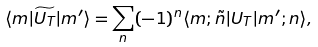Convert formula to latex. <formula><loc_0><loc_0><loc_500><loc_500>\langle { m } | \widetilde { U _ { T } } | { m ^ { \prime } } \rangle = \sum _ { n } ( - 1 ) ^ { n } \langle { m } ; { \tilde { n } } | U _ { T } | { m ^ { \prime } } ; { n } \rangle ,</formula> 